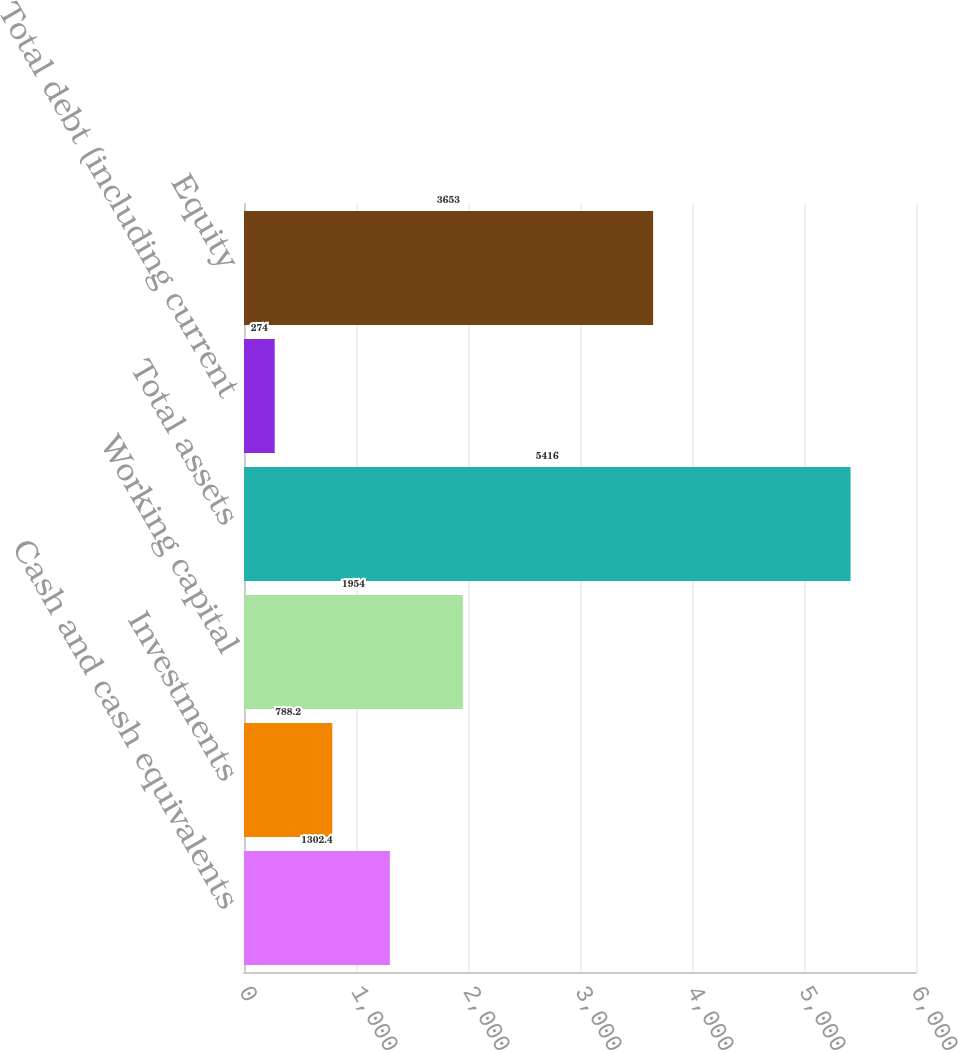Convert chart. <chart><loc_0><loc_0><loc_500><loc_500><bar_chart><fcel>Cash and cash equivalents<fcel>Investments<fcel>Working capital<fcel>Total assets<fcel>Total debt (including current<fcel>Equity<nl><fcel>1302.4<fcel>788.2<fcel>1954<fcel>5416<fcel>274<fcel>3653<nl></chart> 